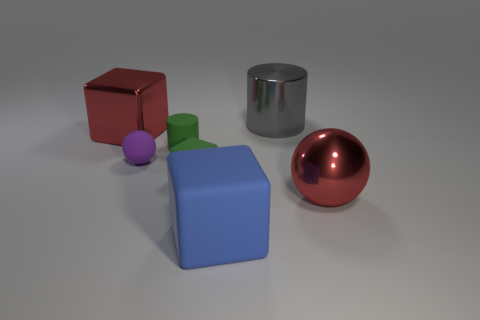Is there a green block?
Give a very brief answer. Yes. Does the blue object in front of the big gray cylinder have the same material as the tiny ball that is behind the blue object?
Provide a succinct answer. Yes. How big is the cylinder behind the large red shiny thing behind the metallic thing that is to the right of the large gray metallic thing?
Provide a short and direct response. Large. What number of other things have the same material as the big blue object?
Your answer should be very brief. 3. Is the number of matte objects less than the number of blue matte things?
Keep it short and to the point. No. The red thing that is the same shape as the purple object is what size?
Offer a very short reply. Large. Are the ball that is to the left of the red sphere and the big blue object made of the same material?
Your answer should be compact. Yes. Do the big blue matte thing and the purple thing have the same shape?
Offer a very short reply. No. What number of things are either big red objects that are to the left of the gray metallic thing or blue blocks?
Your response must be concise. 2. There is a gray object that is made of the same material as the big red sphere; what size is it?
Provide a short and direct response. Large. 